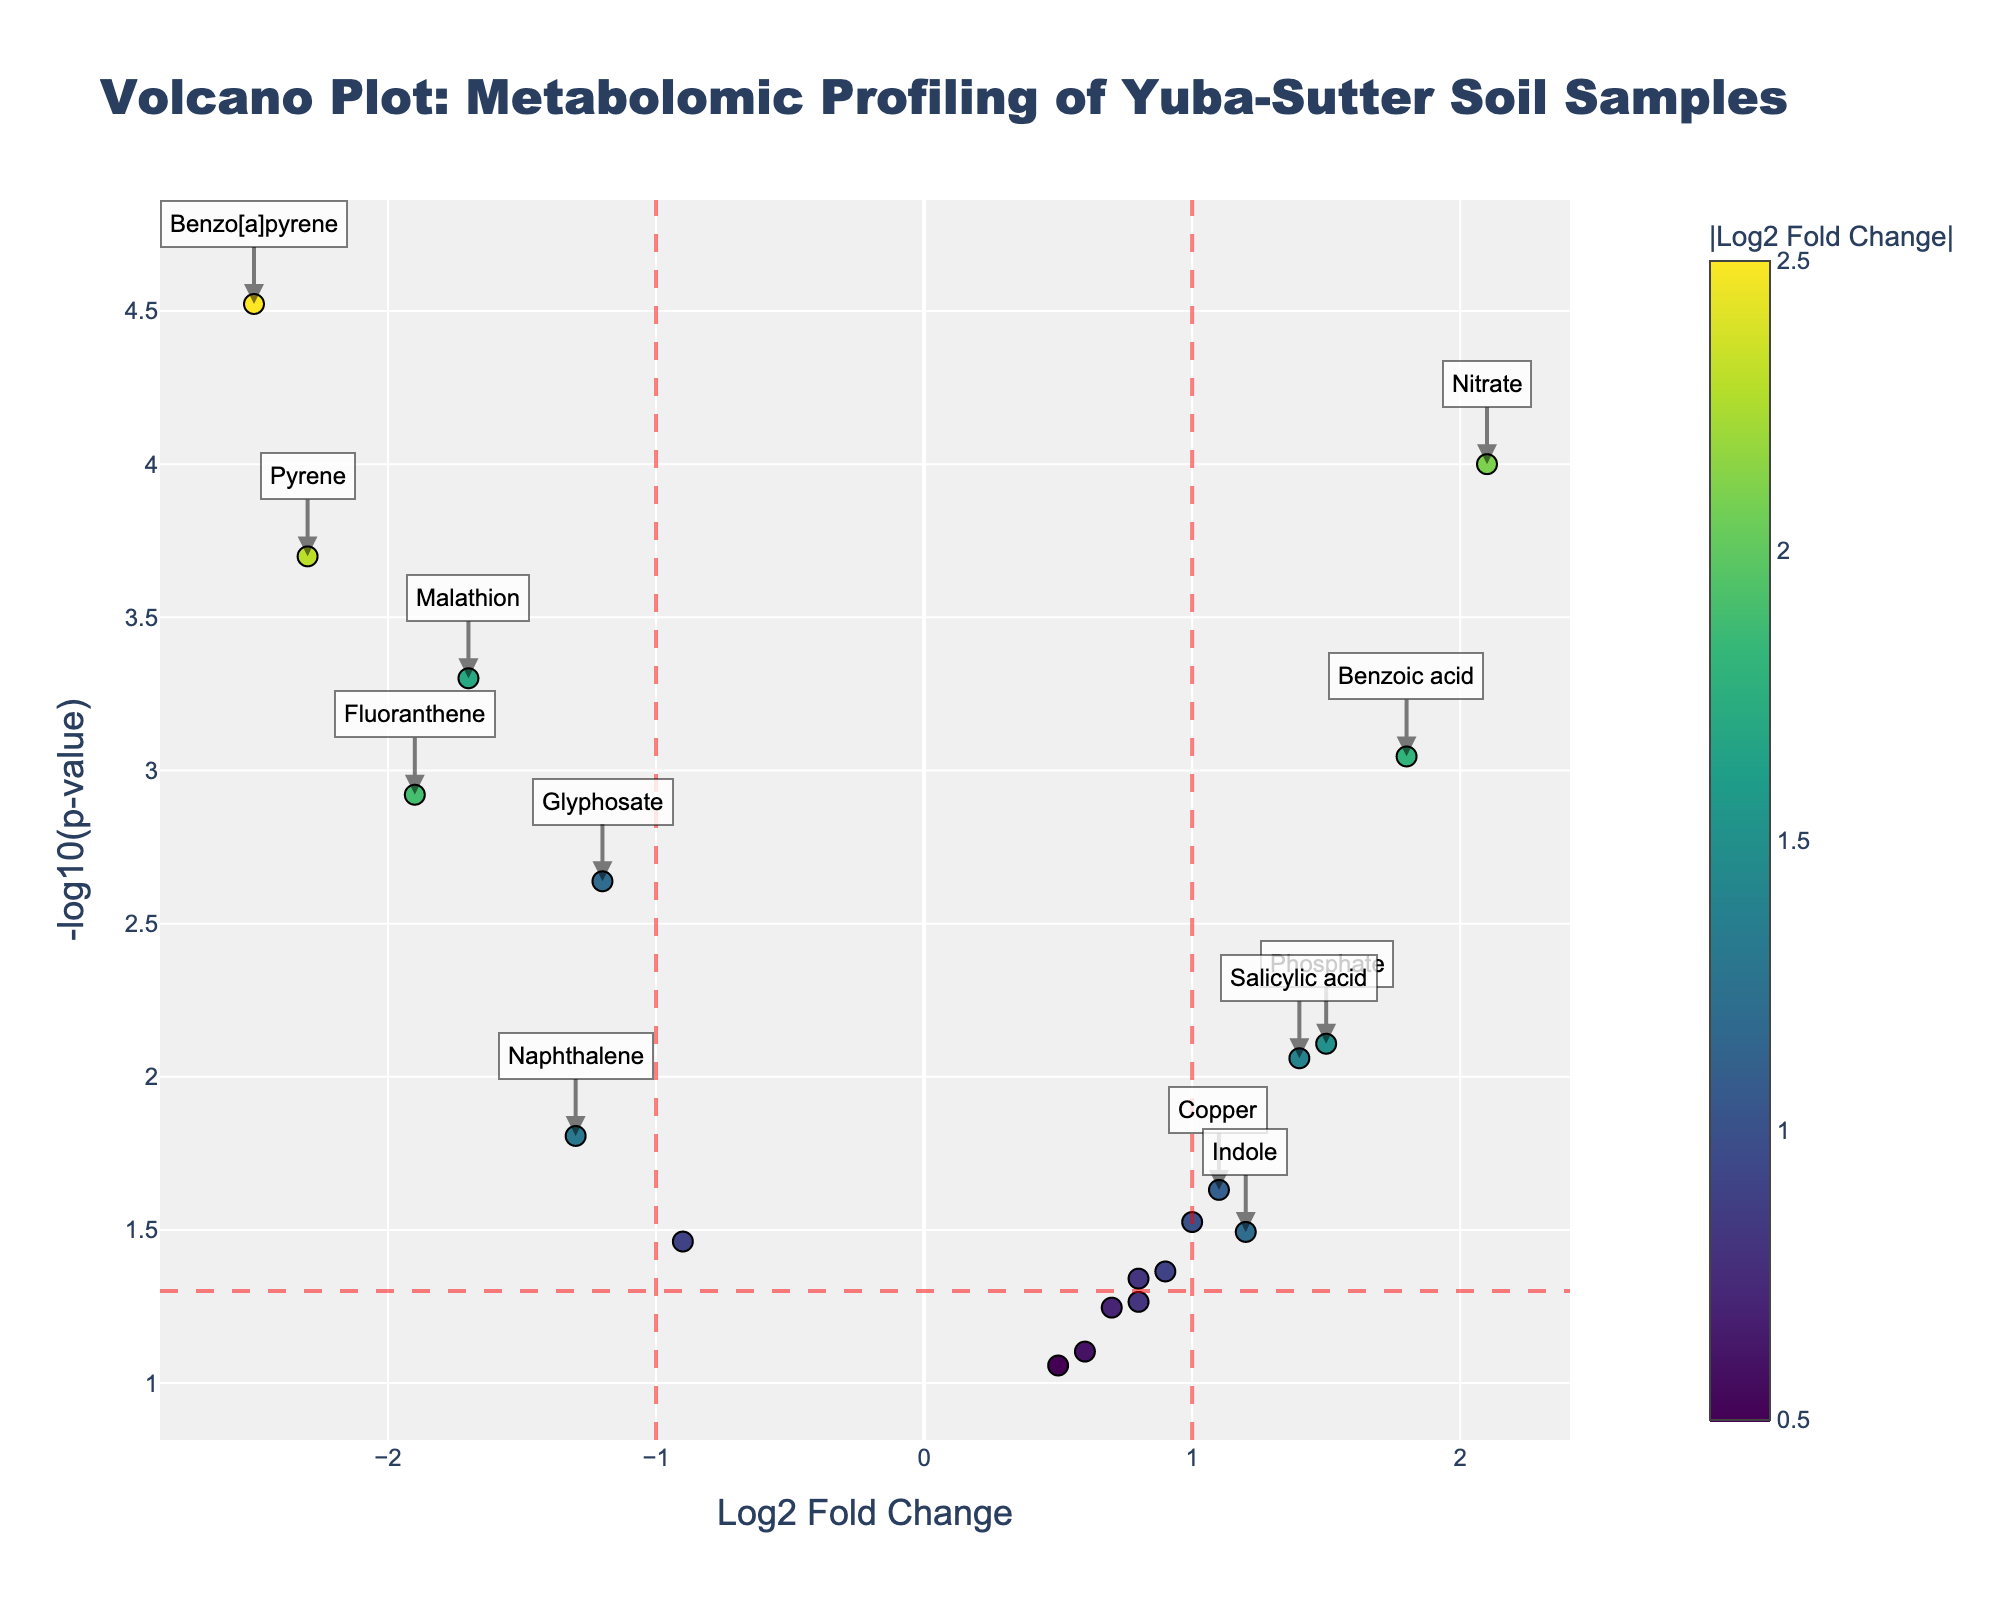What is the title of the plot? The title is the text at the top center of the plot, which in this case reads "Volcano Plot: Metabolomic Profiling of Yuba-Sutter Soil Samples".
Answer: Volcano Plot: Metabolomic Profiling of Yuba-Sutter Soil Samples What does the x-axis represent? The label below the horizontal axis explains this, indicating "Log2 Fold Change".
Answer: Log2 Fold Change What does the y-axis represent? The label next to the vertical axis explains this, indicating "-log10(p-value)".
Answer: -log10(p-value) How many compounds are indicated on the plot? By counting the markers (data points) visible on the plot, we can determine the number of compounds. There are 20 markers corresponding to 20 compounds.
Answer: 20 Which compound has the highest log2 fold change? By looking at the points on the x-axis, the highest positive value is 2.1, which corresponds to Nitrate.
Answer: Nitrate Which compound is the most significantly downregulated? The most downregulated compound would have the lowest log2 fold change with the highest -log10(p-value). Benzo[a]pyrene has the most negative log2 fold change at -2.5 and a very low p-value.
Answer: Benzo[a]pyrene What compounds exceed both the fold change and p-value significance thresholds? Compounds that cross both thresholds are those outside the red vertical lines (x = ±1) and above the red horizontal line (y = -log10(0.05)). Compounds fitting this include Nitrate, Phosphate, Malathion, Pyrene, Fluoranthene, Benzo[a]pyrene, Benzoic acid.
Answer: Nitrate, Phosphate, Malathion, Pyrene, Fluoranthene, Benzo[a]pyrene, Benzoic acid How many compounds are significantly upregulated based on the threshold? Significantly upregulated compounds have a log2 fold change > 1 and a p-value < 0.05. Those fitting this description are Nitrate, Phosphate, Benzoic acid.
Answer: 3 Which two compounds are closest to the fold change threshold but on opposite sides? To find these, look near the vertical lines x = ±1. Glyphosate (-1.2) and Indole (1.2) are closest to these limits on opposite sides.
Answer: Glyphosate and Indole Does any compound have a log2 fold change and p-value exactly on the thresholds? No, scanning the data reveals that no compound has a log2 fold change of exactly ±1 and a p-value exactly at 0.05.
Answer: No 